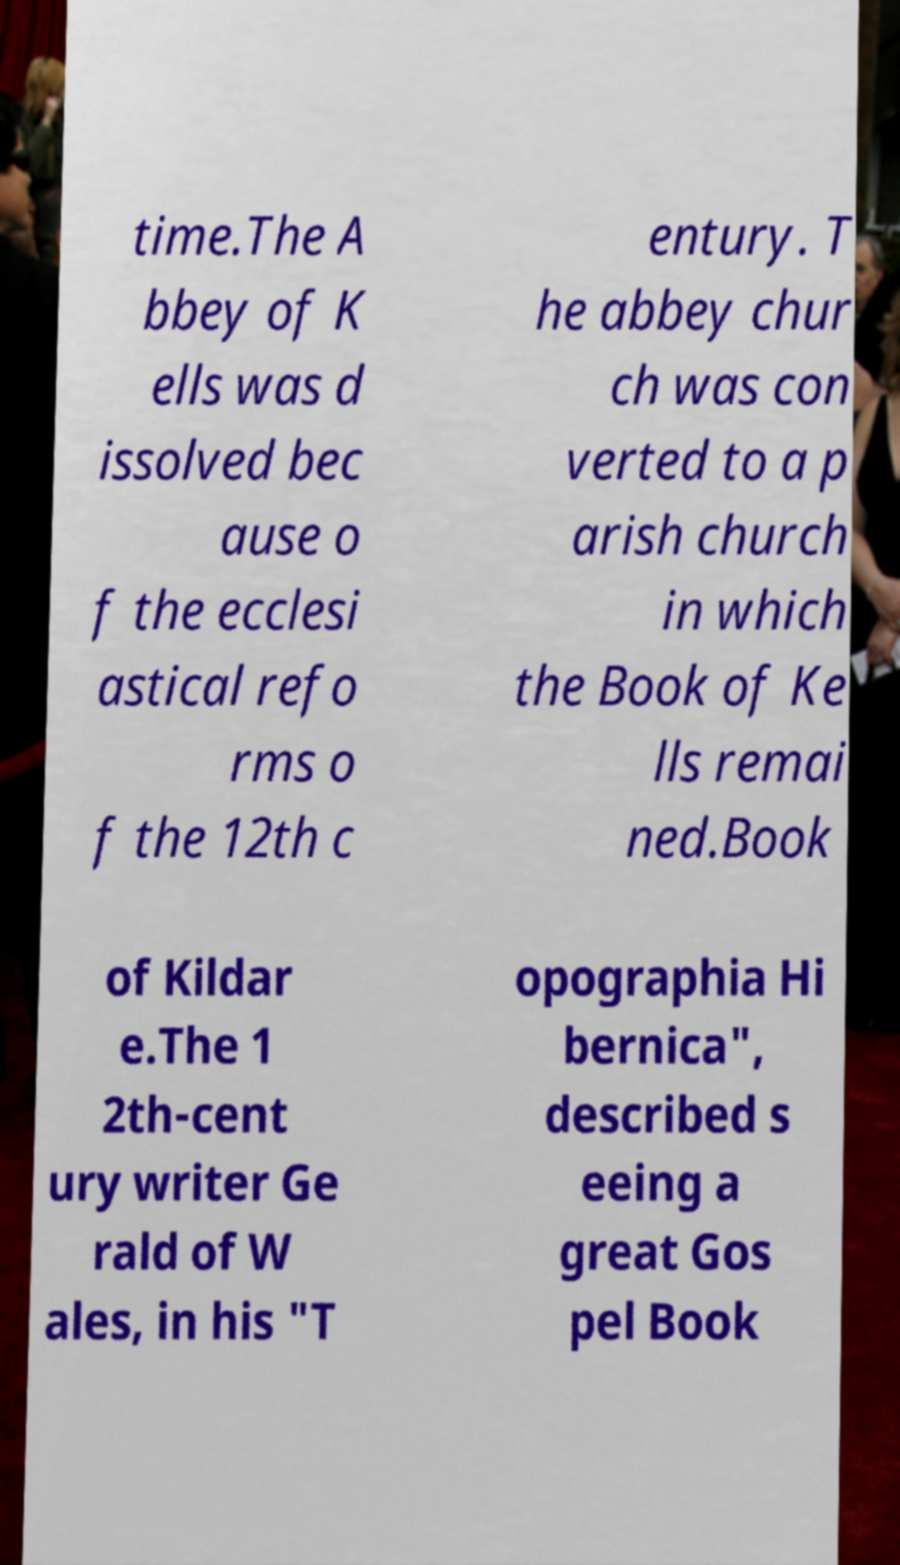Could you assist in decoding the text presented in this image and type it out clearly? time.The A bbey of K ells was d issolved bec ause o f the ecclesi astical refo rms o f the 12th c entury. T he abbey chur ch was con verted to a p arish church in which the Book of Ke lls remai ned.Book of Kildar e.The 1 2th-cent ury writer Ge rald of W ales, in his "T opographia Hi bernica", described s eeing a great Gos pel Book 